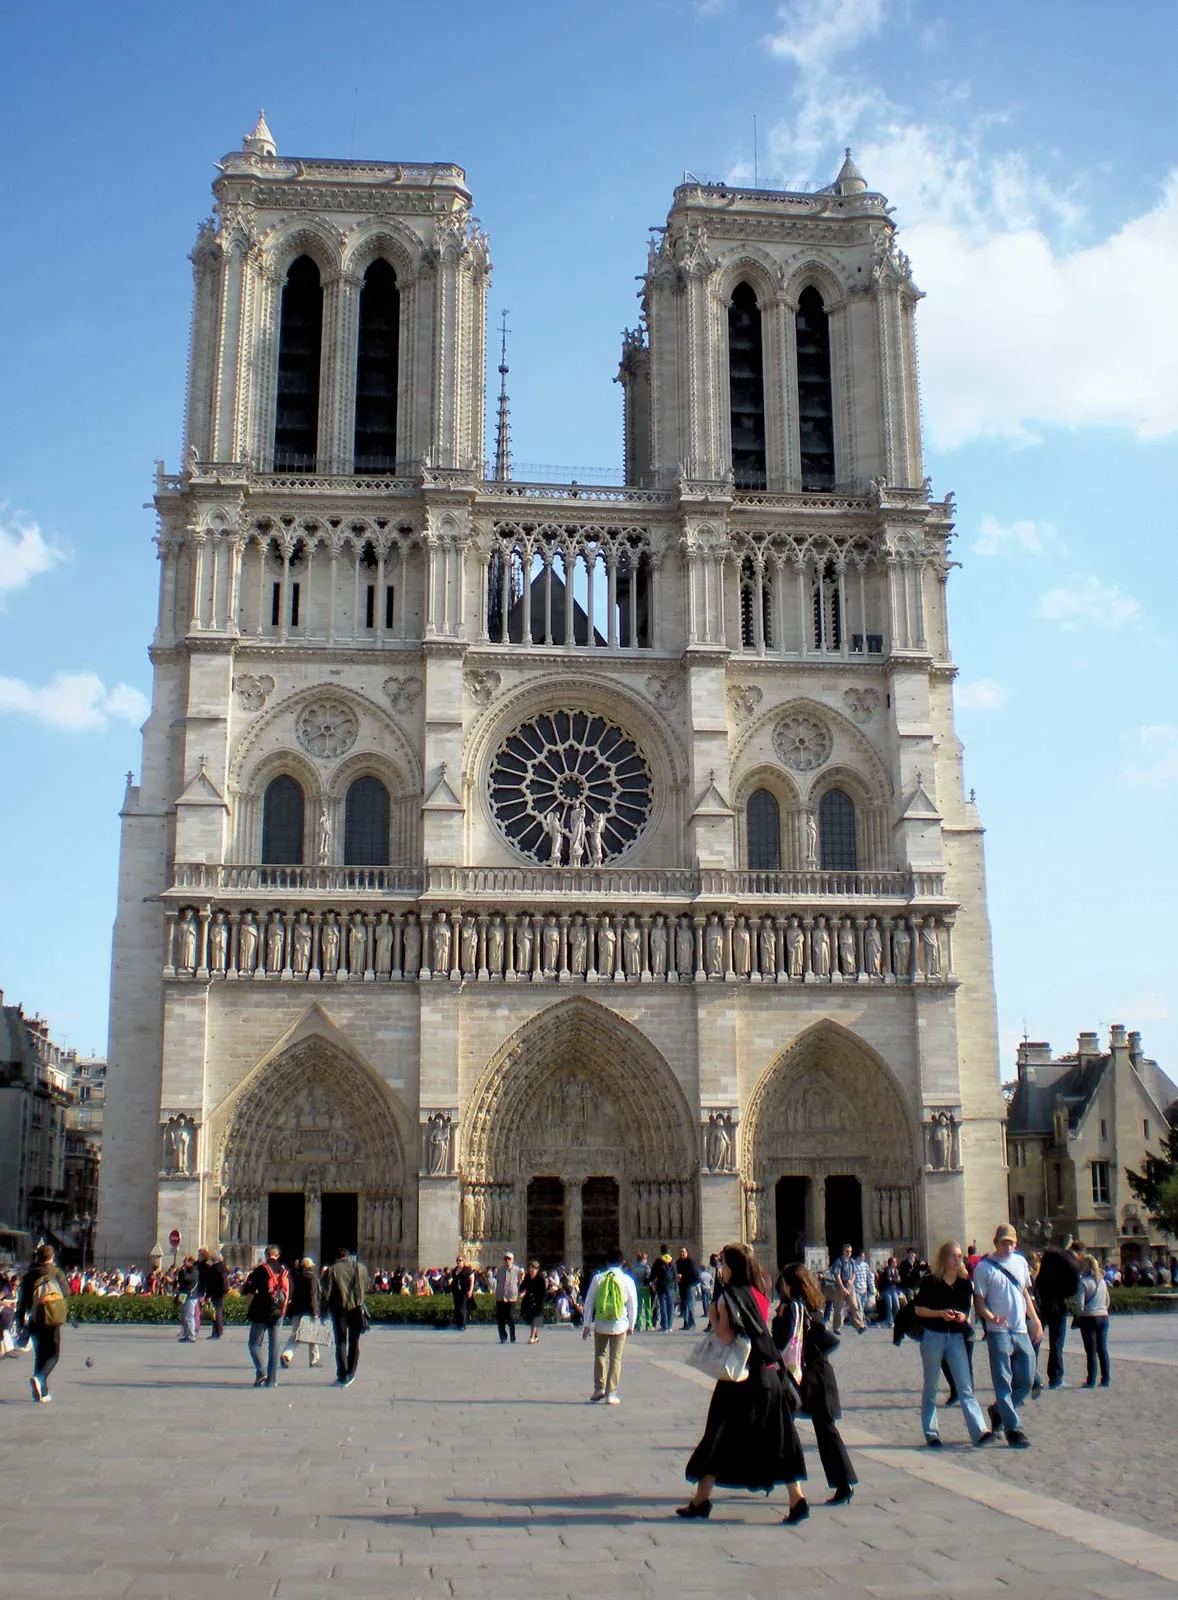Suppose a fantasy creature lives within this cathedral. Describe its origin and its role inside the cathedral. Imagine if deep within the labyrinthine passages of Notre Dame Cathedral, there resided a benevolent griffin named Luminar. Born from the ethereal light of the cathedral's rose window, Luminar possesses shimmering feathers that reflect the hues of the stained glass. As the guardian of Notre Dame, Luminar has protected the sacred artifacts and watched over the countless souls that seek refuge within its walls for centuries. Legend has it that on nights of a full moon, Luminar's eyes glow with an ancient wisdom, revealing prophecies and guiding lost souls. The griffin’s presence is often sensed rather than seen, a silent protector ensuring the cathedral remains a sanctuary of peace and spirituality. How might visitors react upon encountering Luminar? Visitors who encounter Luminar, the griffin guardian of Notre Dame, would likely experience a mix of awe, wonder, and reverence. Those with a deep sense of faith would see Luminar as a divine sign, a living embodiment of the cathedral's spiritual protection. Children might be fascinated by the magical creature, struck by its shimmering feathers and gentle eyes. Skeptics, however, might question their senses, pondering whether Luminar is a figment of their imagination or a hidden secret of the cathedral. Overall, Luminar’s appearance would leave an unforgettable impression, enhancing the mystique and allure of the historic site. 